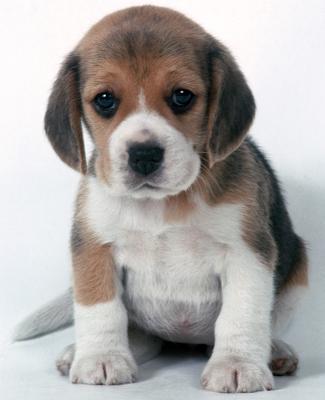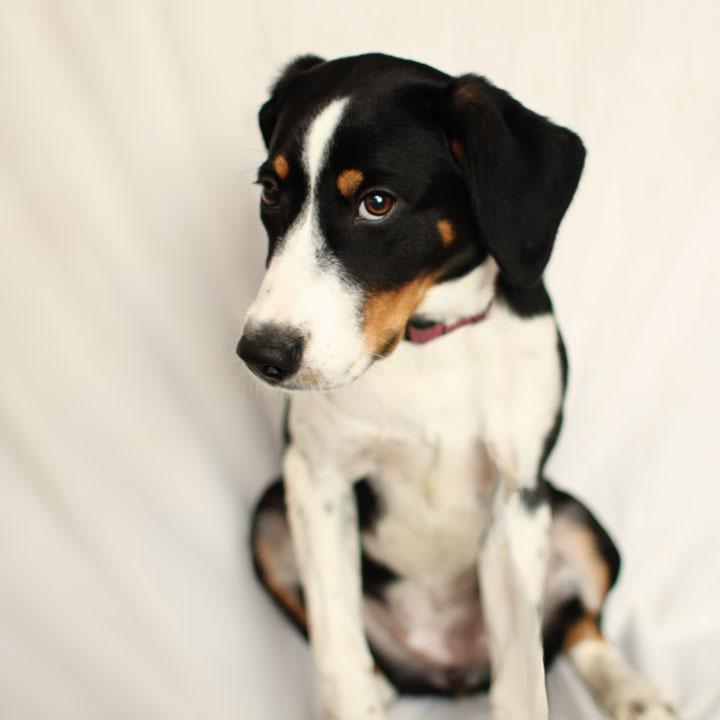The first image is the image on the left, the second image is the image on the right. Analyze the images presented: Is the assertion "The dog in the image on the right has a predominately black head." valid? Answer yes or no. Yes. The first image is the image on the left, the second image is the image on the right. Assess this claim about the two images: "One dog has a black 'mask' around its eyes, and one of the dogs has a longer muzzle than the other dog.". Correct or not? Answer yes or no. Yes. 